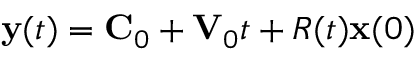Convert formula to latex. <formula><loc_0><loc_0><loc_500><loc_500>{ y } ( t ) = { C } _ { 0 } + { V } _ { 0 } t + R ( t ) { x } ( 0 )</formula> 